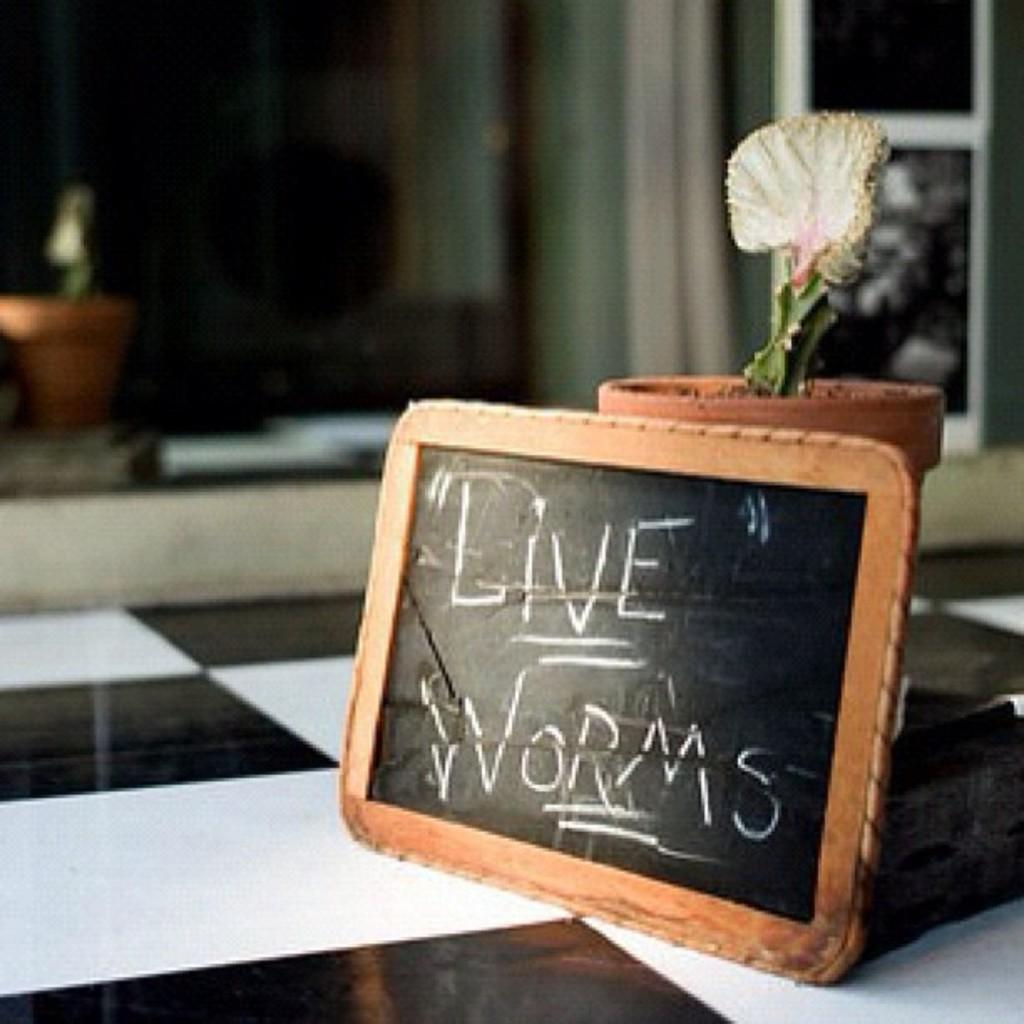What is written or drawn on the slate in the image? There is text on a slate in the image. What type of plant is on the floor in the image? There is a house plant on the floor in the image. Can you describe the background of the image? The background of the image is blurry, and there are objects visible. What type of business is being conducted in the image? There is no indication of a business being conducted in the image. Can you describe the parent the slate in the image? The slate cannot be parented, as it is an inanimate object. Is there any evidence of someone biting the house plant in the image? There is no evidence of anyone biting the house plant in the image. 